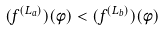<formula> <loc_0><loc_0><loc_500><loc_500>( f ^ { ( L _ { a } ) } ) ( \phi ) < ( f ^ { ( L _ { b } ) } ) ( \phi )</formula> 